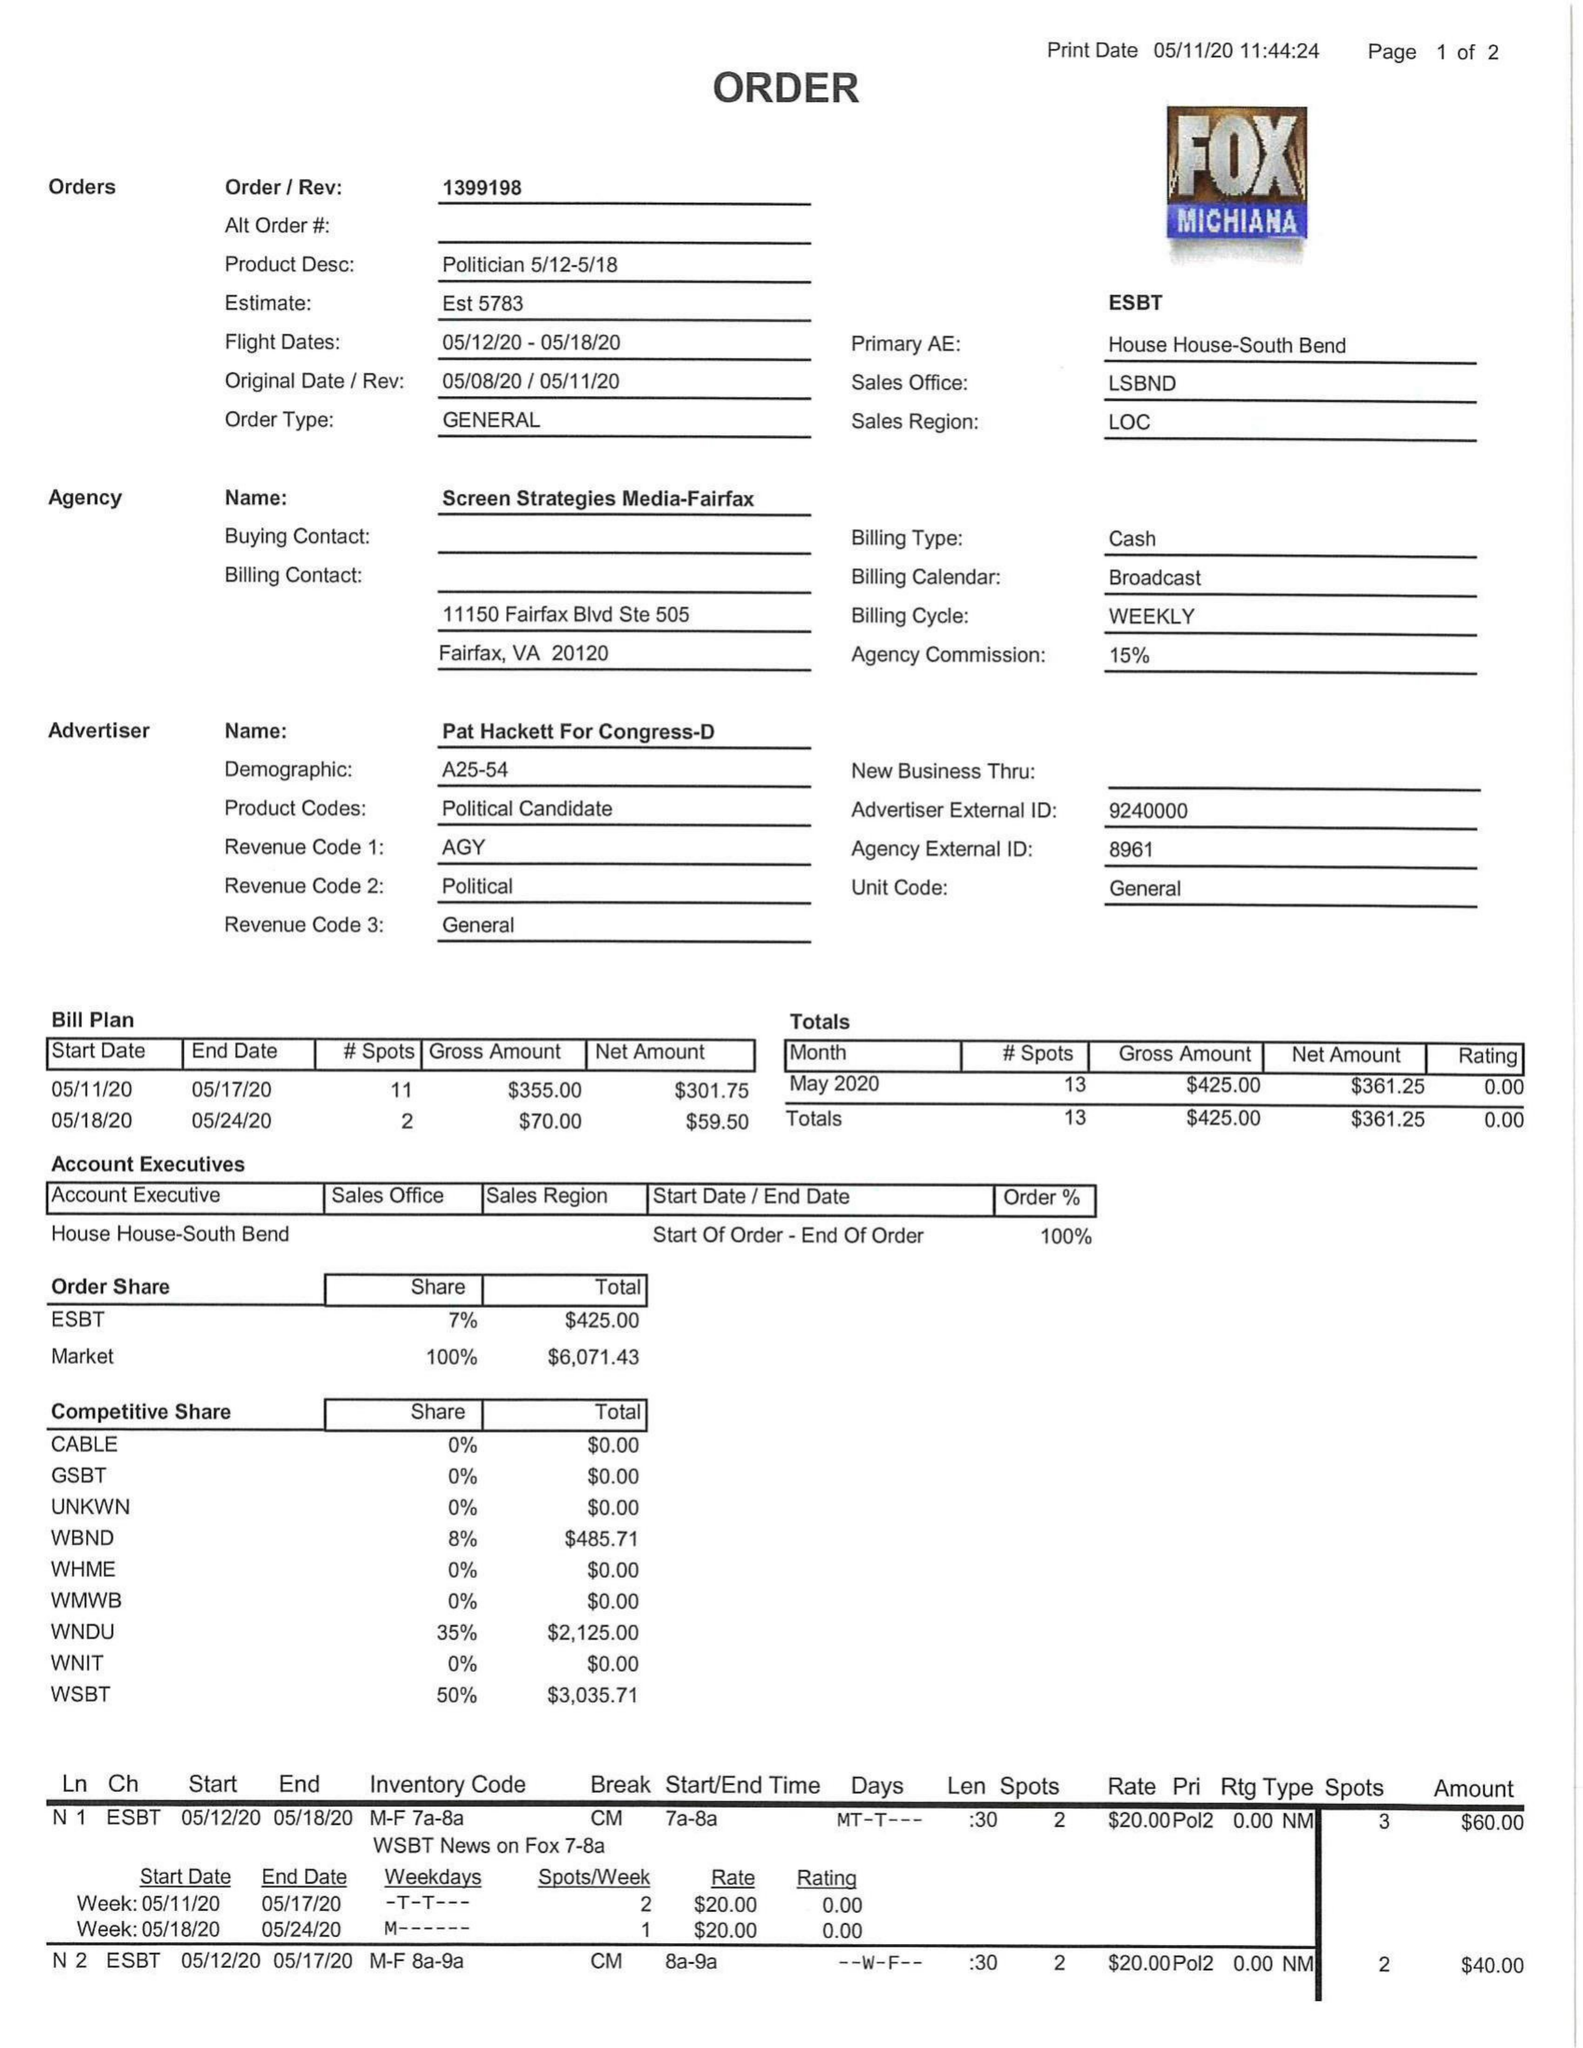What is the value for the gross_amount?
Answer the question using a single word or phrase. 425.00 